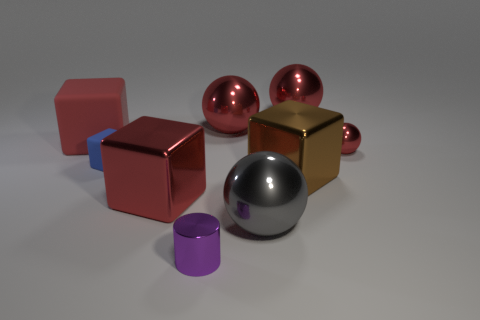Subtract all large gray spheres. How many spheres are left? 3 Add 1 gray balls. How many objects exist? 10 Subtract 3 balls. How many balls are left? 1 Subtract all cubes. How many objects are left? 5 Add 6 red cubes. How many red cubes exist? 8 Subtract all gray spheres. How many spheres are left? 3 Subtract 2 red blocks. How many objects are left? 7 Subtract all yellow cylinders. Subtract all yellow blocks. How many cylinders are left? 1 Subtract all gray blocks. How many gray balls are left? 1 Subtract all tiny cubes. Subtract all purple cylinders. How many objects are left? 7 